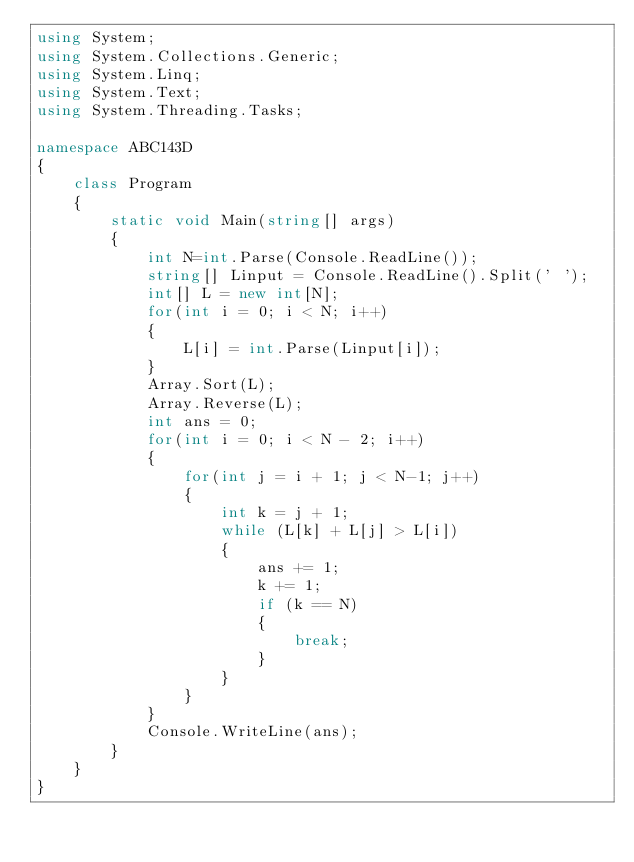<code> <loc_0><loc_0><loc_500><loc_500><_C#_>using System;
using System.Collections.Generic;
using System.Linq;
using System.Text;
using System.Threading.Tasks;

namespace ABC143D
{
    class Program
    {
        static void Main(string[] args)
        {
            int N=int.Parse(Console.ReadLine());
            string[] Linput = Console.ReadLine().Split(' ');
            int[] L = new int[N];
            for(int i = 0; i < N; i++)
            {
                L[i] = int.Parse(Linput[i]);
            }
            Array.Sort(L);
            Array.Reverse(L);
            int ans = 0;
            for(int i = 0; i < N - 2; i++)
            {
                for(int j = i + 1; j < N-1; j++)
                {
                    int k = j + 1;
                    while (L[k] + L[j] > L[i])
                    {
                        ans += 1;
                        k += 1;
                        if (k == N)
                        {
                            break;
                        }
                    }
                }
            }
            Console.WriteLine(ans);
        }
    }
}
</code> 